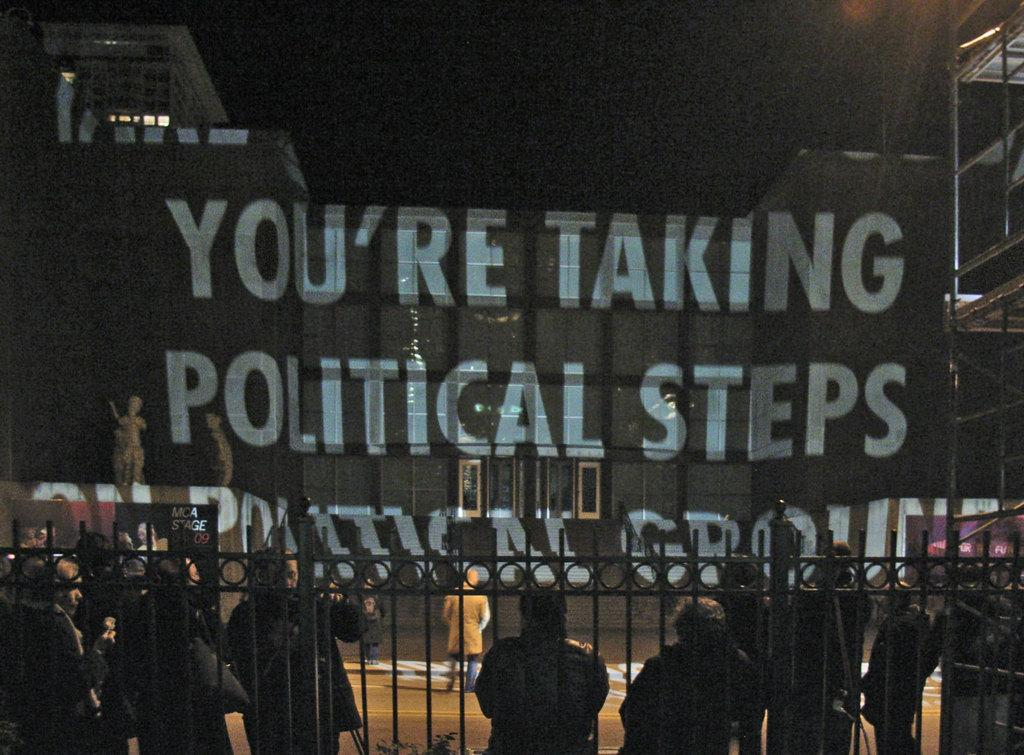What is happening in the image? There is a group of people standing in the image. What can be seen behind the people? There is a fence at the back of the image. What is in front of the people? There is a wall in front of the image. What is the lighting condition above the image? The area above the image is dark. Can you see a baby drinking eggnog in the image? There is no baby or eggnog present in the image. What type of twig is being used by the people in the image? There is no twig visible in the image. 